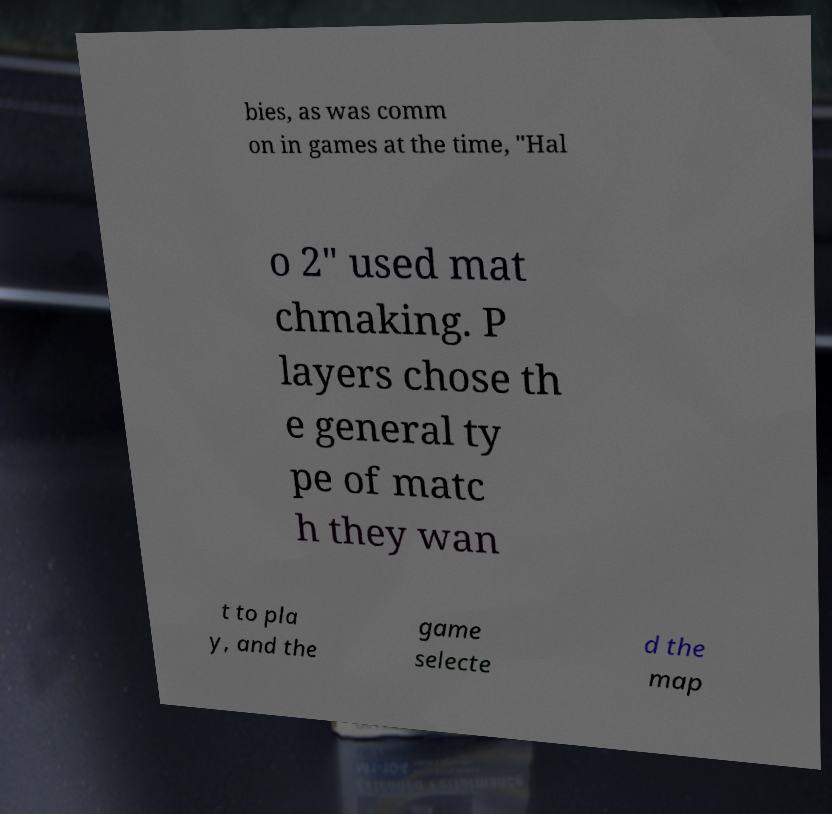I need the written content from this picture converted into text. Can you do that? bies, as was comm on in games at the time, "Hal o 2" used mat chmaking. P layers chose th e general ty pe of matc h they wan t to pla y, and the game selecte d the map 